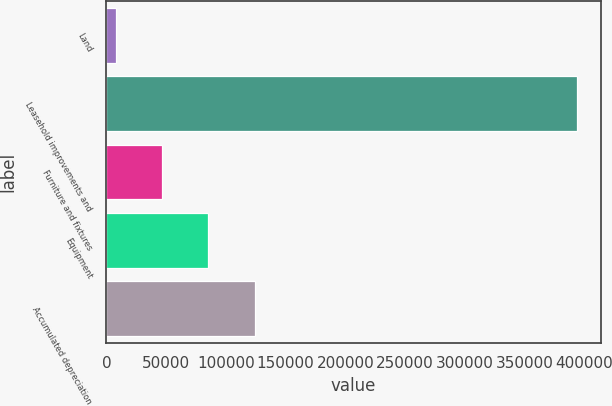<chart> <loc_0><loc_0><loc_500><loc_500><bar_chart><fcel>Land<fcel>Leasehold improvements and<fcel>Furniture and fixtures<fcel>Equipment<fcel>Accumulated depreciation<nl><fcel>8215<fcel>393980<fcel>46791.5<fcel>85368<fcel>123944<nl></chart> 